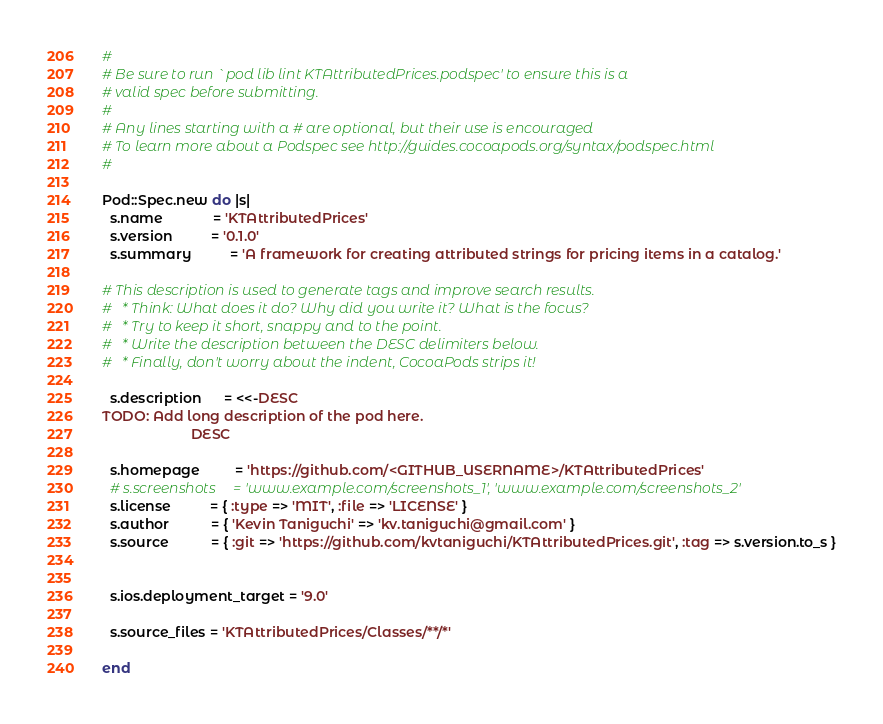Convert code to text. <code><loc_0><loc_0><loc_500><loc_500><_Ruby_>#
# Be sure to run `pod lib lint KTAttributedPrices.podspec' to ensure this is a
# valid spec before submitting.
#
# Any lines starting with a # are optional, but their use is encouraged
# To learn more about a Podspec see http://guides.cocoapods.org/syntax/podspec.html
#

Pod::Spec.new do |s|
  s.name             = 'KTAttributedPrices'
  s.version          = '0.1.0'
  s.summary          = 'A framework for creating attributed strings for pricing items in a catalog.'

# This description is used to generate tags and improve search results.
#   * Think: What does it do? Why did you write it? What is the focus?
#   * Try to keep it short, snappy and to the point.
#   * Write the description between the DESC delimiters below.
#   * Finally, don't worry about the indent, CocoaPods strips it!

  s.description      = <<-DESC
TODO: Add long description of the pod here.
                       DESC

  s.homepage         = 'https://github.com/<GITHUB_USERNAME>/KTAttributedPrices'
  # s.screenshots     = 'www.example.com/screenshots_1', 'www.example.com/screenshots_2'
  s.license          = { :type => 'MIT', :file => 'LICENSE' }
  s.author           = { 'Kevin Taniguchi' => 'kv.taniguchi@gmail.com' }
  s.source           = { :git => 'https://github.com/kvtaniguchi/KTAttributedPrices.git', :tag => s.version.to_s }


  s.ios.deployment_target = '9.0'

  s.source_files = 'KTAttributedPrices/Classes/**/*'

end
</code> 